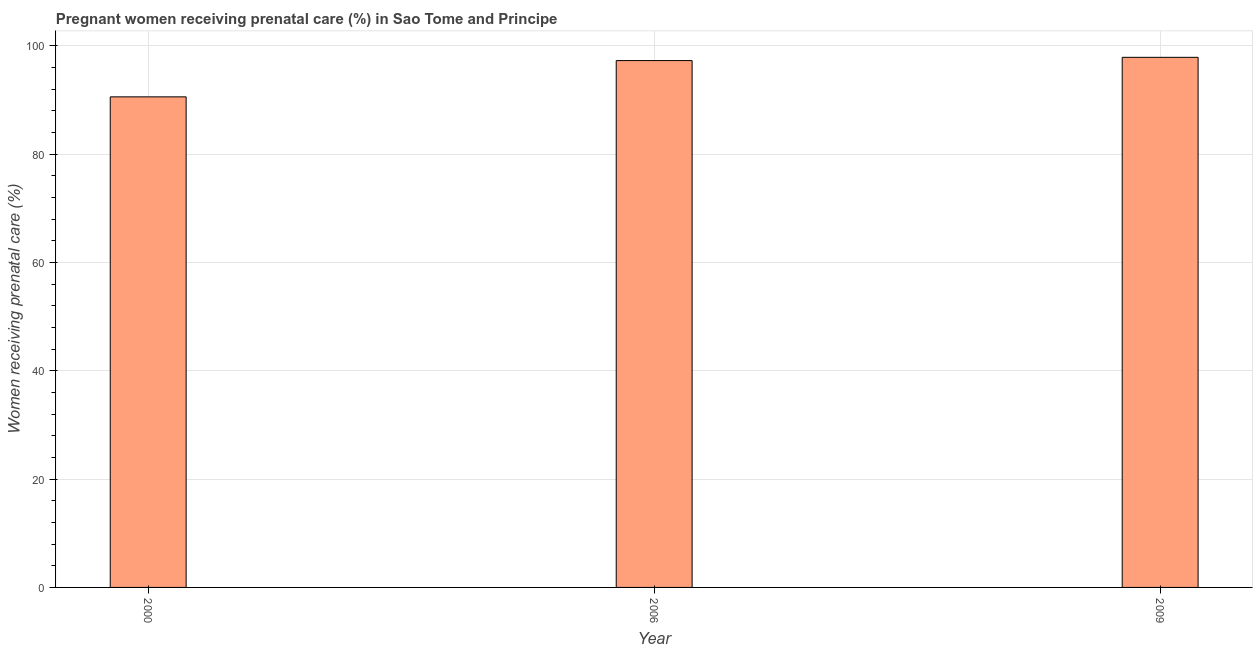What is the title of the graph?
Give a very brief answer. Pregnant women receiving prenatal care (%) in Sao Tome and Principe. What is the label or title of the X-axis?
Provide a short and direct response. Year. What is the label or title of the Y-axis?
Ensure brevity in your answer.  Women receiving prenatal care (%). What is the percentage of pregnant women receiving prenatal care in 2006?
Keep it short and to the point. 97.3. Across all years, what is the maximum percentage of pregnant women receiving prenatal care?
Keep it short and to the point. 97.9. Across all years, what is the minimum percentage of pregnant women receiving prenatal care?
Make the answer very short. 90.6. In which year was the percentage of pregnant women receiving prenatal care minimum?
Give a very brief answer. 2000. What is the sum of the percentage of pregnant women receiving prenatal care?
Give a very brief answer. 285.8. What is the difference between the percentage of pregnant women receiving prenatal care in 2006 and 2009?
Keep it short and to the point. -0.6. What is the average percentage of pregnant women receiving prenatal care per year?
Your answer should be very brief. 95.27. What is the median percentage of pregnant women receiving prenatal care?
Offer a terse response. 97.3. Do a majority of the years between 2009 and 2006 (inclusive) have percentage of pregnant women receiving prenatal care greater than 12 %?
Your answer should be very brief. No. Is the percentage of pregnant women receiving prenatal care in 2006 less than that in 2009?
Your response must be concise. Yes. Is the difference between the percentage of pregnant women receiving prenatal care in 2000 and 2006 greater than the difference between any two years?
Offer a very short reply. No. What is the difference between the highest and the lowest percentage of pregnant women receiving prenatal care?
Provide a succinct answer. 7.3. Are all the bars in the graph horizontal?
Provide a short and direct response. No. How many years are there in the graph?
Offer a very short reply. 3. Are the values on the major ticks of Y-axis written in scientific E-notation?
Your answer should be very brief. No. What is the Women receiving prenatal care (%) in 2000?
Your answer should be very brief. 90.6. What is the Women receiving prenatal care (%) of 2006?
Offer a very short reply. 97.3. What is the Women receiving prenatal care (%) of 2009?
Ensure brevity in your answer.  97.9. What is the difference between the Women receiving prenatal care (%) in 2000 and 2009?
Offer a very short reply. -7.3. What is the difference between the Women receiving prenatal care (%) in 2006 and 2009?
Offer a terse response. -0.6. What is the ratio of the Women receiving prenatal care (%) in 2000 to that in 2009?
Give a very brief answer. 0.93. What is the ratio of the Women receiving prenatal care (%) in 2006 to that in 2009?
Your answer should be compact. 0.99. 